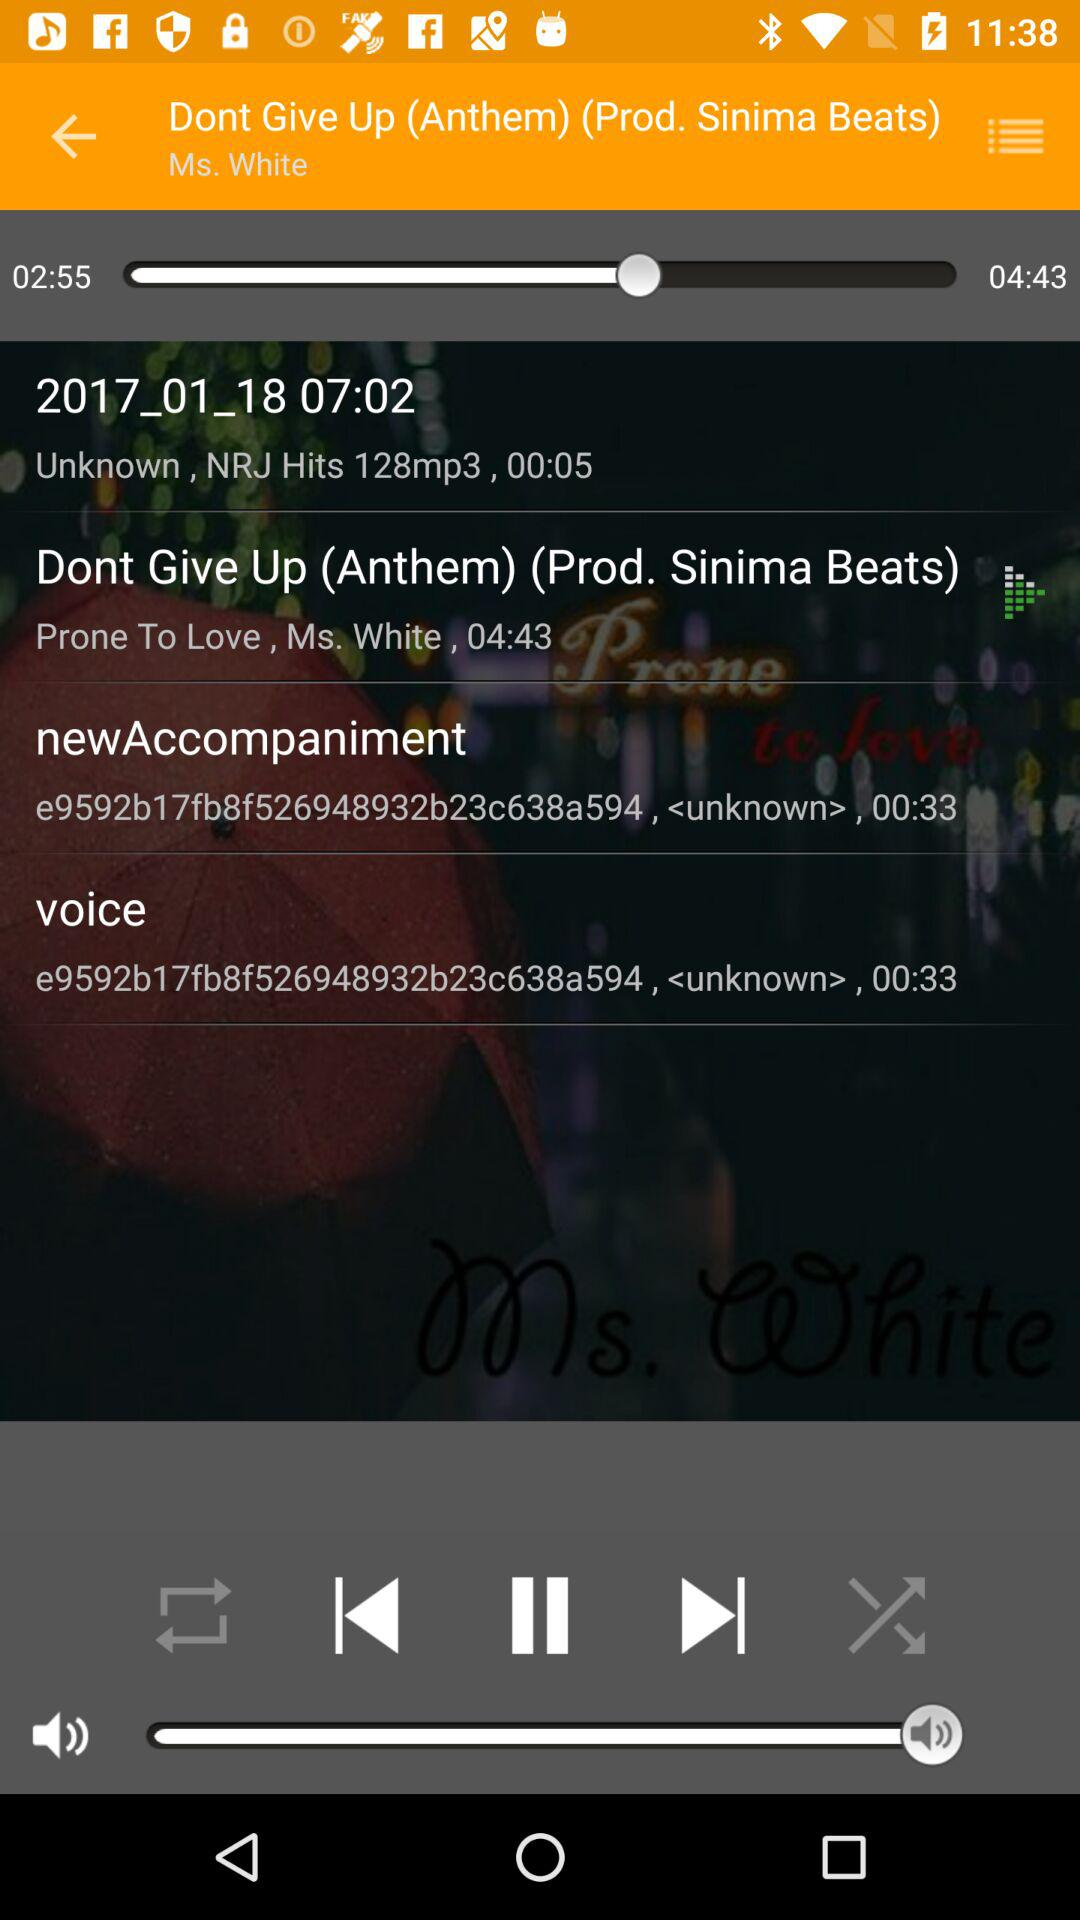What is the duration of the song "Dont Give Up (Anthem) (Prod. Sinima Beats)"? The duration of the song "Dont Give Up (Anthem) (Prod. Sinima Beats)" is 4 minutes 43 seconds. 